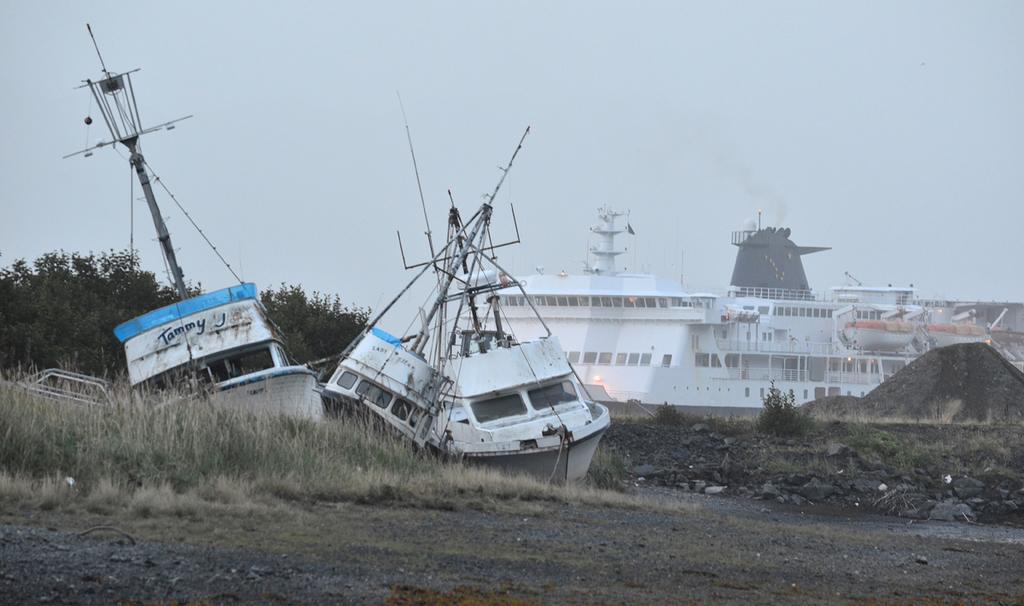Can you describe this image briefly? In this picture we can see many boats on the ground. On the left we can see the factory. At the top of the factory we can smoke which is coming out from the exhaust pipe. In the background we can see the trees. At the top there is a sky. 